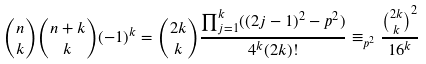<formula> <loc_0><loc_0><loc_500><loc_500>\binom { n } { k } \binom { n + k } { k } ( - 1 ) ^ { k } = \binom { 2 k } { k } \frac { \prod _ { j = 1 } ^ { k } ( ( 2 j - 1 ) ^ { 2 } - p ^ { 2 } ) } { 4 ^ { k } ( 2 k ) ! } \equiv _ { p ^ { 2 } } \frac { \binom { 2 k } { k } ^ { 2 } } { 1 6 ^ { k } }</formula> 